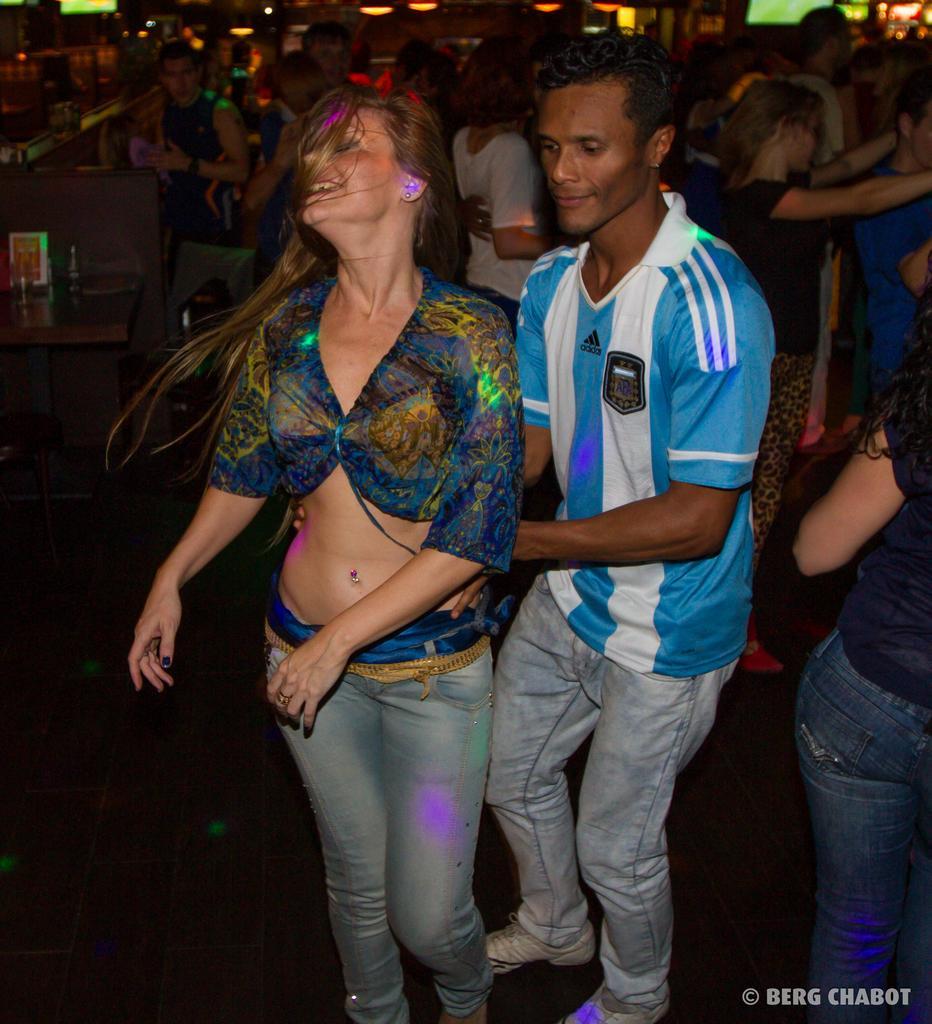In one or two sentences, can you explain what this image depicts? In this image, I can see groups of people dancing. On the left side of the image, It looks like a table with few objects on it. At the top of the image, I can see the lights. At the bottom right side of the image, this is the watermark. 